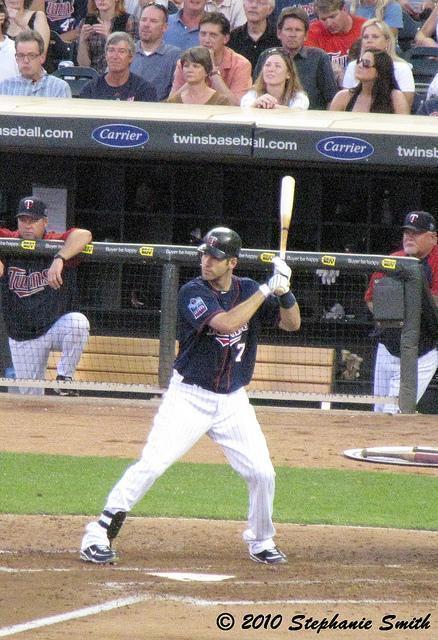What is the name of the batter?
From the following four choices, select the correct answer to address the question.
Options: Joe mauer, chipper jones, tanyon sturtze, jerry cantrell. Joe mauer. 